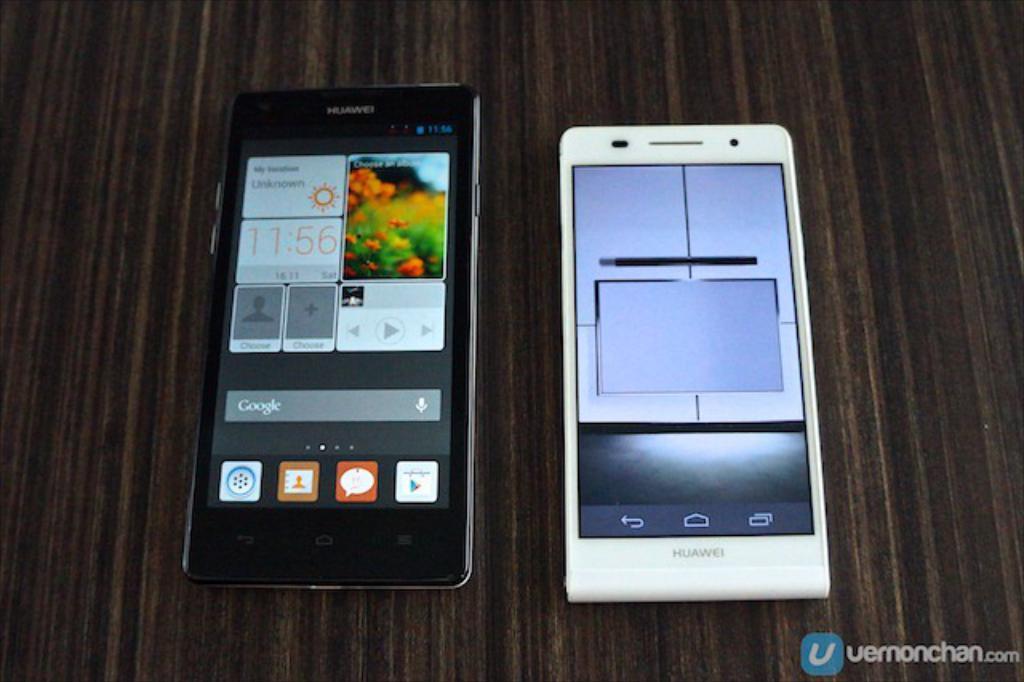<image>
Present a compact description of the photo's key features. a white huawei phone next to a black huawei phone 